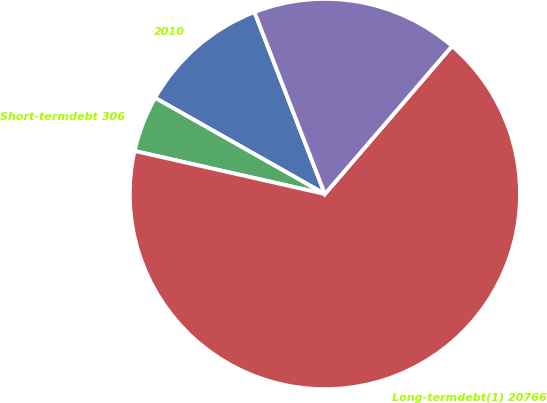Convert chart. <chart><loc_0><loc_0><loc_500><loc_500><pie_chart><fcel>2010<fcel>Short-termdebt 306<fcel>Long-termdebt(1) 20766<fcel>Unnamed: 3<nl><fcel>10.92%<fcel>4.66%<fcel>67.24%<fcel>17.18%<nl></chart> 